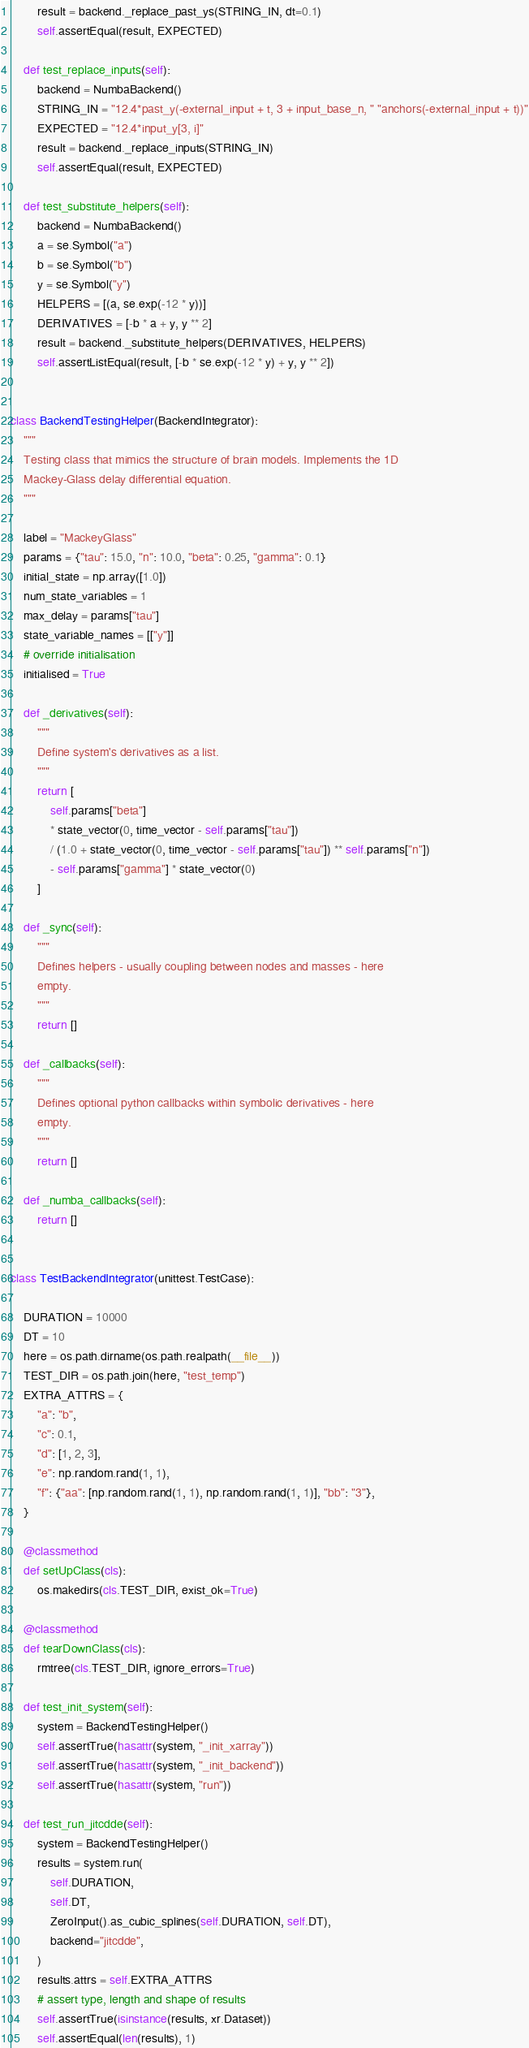Convert code to text. <code><loc_0><loc_0><loc_500><loc_500><_Python_>        result = backend._replace_past_ys(STRING_IN, dt=0.1)
        self.assertEqual(result, EXPECTED)

    def test_replace_inputs(self):
        backend = NumbaBackend()
        STRING_IN = "12.4*past_y(-external_input + t, 3 + input_base_n, " "anchors(-external_input + t))"
        EXPECTED = "12.4*input_y[3, i]"
        result = backend._replace_inputs(STRING_IN)
        self.assertEqual(result, EXPECTED)

    def test_substitute_helpers(self):
        backend = NumbaBackend()
        a = se.Symbol("a")
        b = se.Symbol("b")
        y = se.Symbol("y")
        HELPERS = [(a, se.exp(-12 * y))]
        DERIVATIVES = [-b * a + y, y ** 2]
        result = backend._substitute_helpers(DERIVATIVES, HELPERS)
        self.assertListEqual(result, [-b * se.exp(-12 * y) + y, y ** 2])


class BackendTestingHelper(BackendIntegrator):
    """
    Testing class that mimics the structure of brain models. Implements the 1D
    Mackey-Glass delay differential equation.
    """

    label = "MackeyGlass"
    params = {"tau": 15.0, "n": 10.0, "beta": 0.25, "gamma": 0.1}
    initial_state = np.array([1.0])
    num_state_variables = 1
    max_delay = params["tau"]
    state_variable_names = [["y"]]
    # override initialisation
    initialised = True

    def _derivatives(self):
        """
        Define system's derivatives as a list.
        """
        return [
            self.params["beta"]
            * state_vector(0, time_vector - self.params["tau"])
            / (1.0 + state_vector(0, time_vector - self.params["tau"]) ** self.params["n"])
            - self.params["gamma"] * state_vector(0)
        ]

    def _sync(self):
        """
        Defines helpers - usually coupling between nodes and masses - here
        empty.
        """
        return []

    def _callbacks(self):
        """
        Defines optional python callbacks within symbolic derivatives - here
        empty.
        """
        return []

    def _numba_callbacks(self):
        return []


class TestBackendIntegrator(unittest.TestCase):

    DURATION = 10000
    DT = 10
    here = os.path.dirname(os.path.realpath(__file__))
    TEST_DIR = os.path.join(here, "test_temp")
    EXTRA_ATTRS = {
        "a": "b",
        "c": 0.1,
        "d": [1, 2, 3],
        "e": np.random.rand(1, 1),
        "f": {"aa": [np.random.rand(1, 1), np.random.rand(1, 1)], "bb": "3"},
    }

    @classmethod
    def setUpClass(cls):
        os.makedirs(cls.TEST_DIR, exist_ok=True)

    @classmethod
    def tearDownClass(cls):
        rmtree(cls.TEST_DIR, ignore_errors=True)

    def test_init_system(self):
        system = BackendTestingHelper()
        self.assertTrue(hasattr(system, "_init_xarray"))
        self.assertTrue(hasattr(system, "_init_backend"))
        self.assertTrue(hasattr(system, "run"))

    def test_run_jitcdde(self):
        system = BackendTestingHelper()
        results = system.run(
            self.DURATION,
            self.DT,
            ZeroInput().as_cubic_splines(self.DURATION, self.DT),
            backend="jitcdde",
        )
        results.attrs = self.EXTRA_ATTRS
        # assert type, length and shape of results
        self.assertTrue(isinstance(results, xr.Dataset))
        self.assertEqual(len(results), 1)</code> 